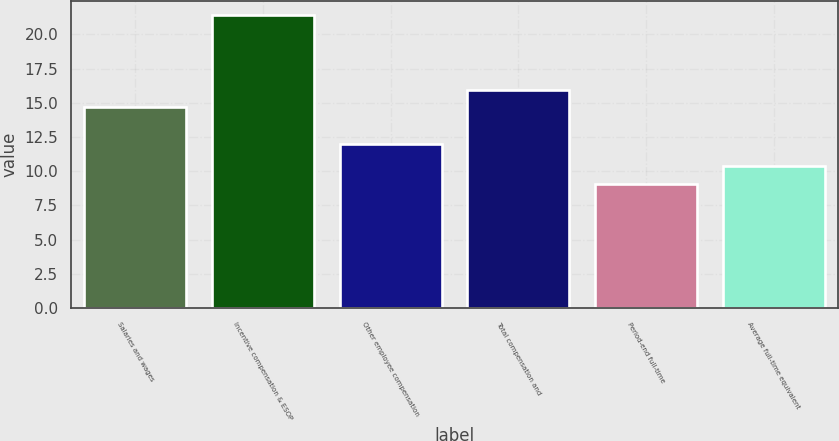Convert chart to OTSL. <chart><loc_0><loc_0><loc_500><loc_500><bar_chart><fcel>Salaries and wages<fcel>Incentive compensation & ESOP<fcel>Other employee compensation<fcel>Total compensation and<fcel>Period-end full-time<fcel>Average full-time equivalent<nl><fcel>14.7<fcel>21.4<fcel>12<fcel>15.93<fcel>9.1<fcel>10.4<nl></chart> 